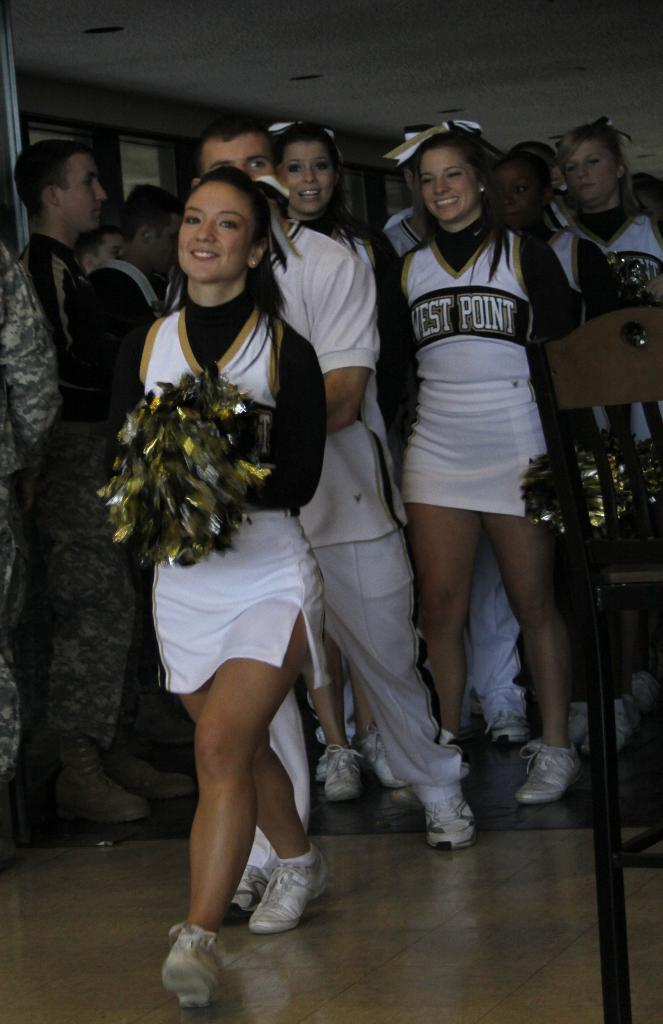Who is present in the image? There are people in the image. Can you describe the individuals in the image? There are girls in the image. What are the girls holding in their hands? The girls are holding papers in their hands. What type of yoke can be seen in the image? There is no yoke present in the image. How many birds are visible in the image? There are no birds visible in the image. 